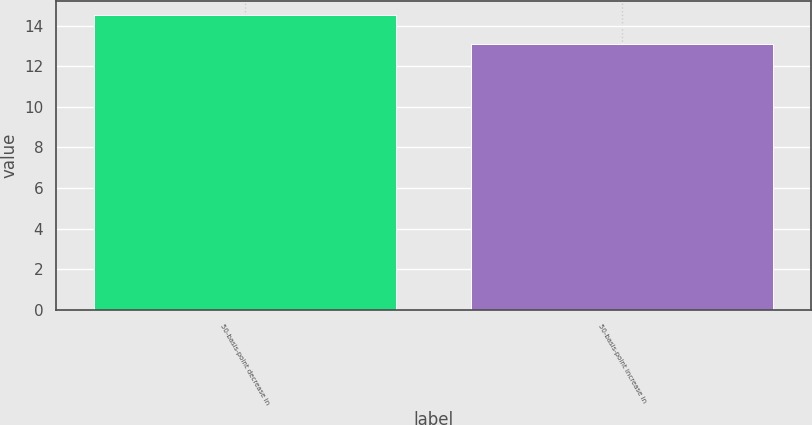<chart> <loc_0><loc_0><loc_500><loc_500><bar_chart><fcel>50-basis-point decrease in<fcel>50-basis-point increase in<nl><fcel>14.5<fcel>13.1<nl></chart> 